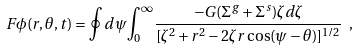Convert formula to latex. <formula><loc_0><loc_0><loc_500><loc_500>F \phi ( r , \theta , t ) = \oint d \psi { \int _ { 0 } } ^ { \infty } \frac { - G ( \Sigma ^ { g } + \Sigma ^ { s } ) \zeta d \zeta } { [ \zeta ^ { 2 } + r ^ { 2 } - 2 \zeta r \cos ( \psi - \theta ) ] ^ { 1 / 2 } } \ ,</formula> 